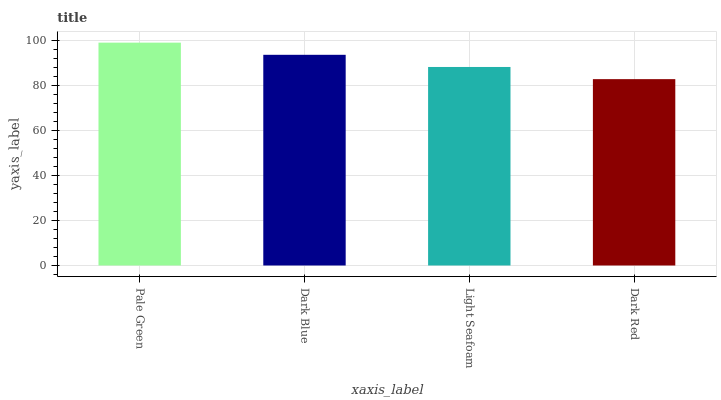Is Dark Red the minimum?
Answer yes or no. Yes. Is Pale Green the maximum?
Answer yes or no. Yes. Is Dark Blue the minimum?
Answer yes or no. No. Is Dark Blue the maximum?
Answer yes or no. No. Is Pale Green greater than Dark Blue?
Answer yes or no. Yes. Is Dark Blue less than Pale Green?
Answer yes or no. Yes. Is Dark Blue greater than Pale Green?
Answer yes or no. No. Is Pale Green less than Dark Blue?
Answer yes or no. No. Is Dark Blue the high median?
Answer yes or no. Yes. Is Light Seafoam the low median?
Answer yes or no. Yes. Is Dark Red the high median?
Answer yes or no. No. Is Dark Blue the low median?
Answer yes or no. No. 